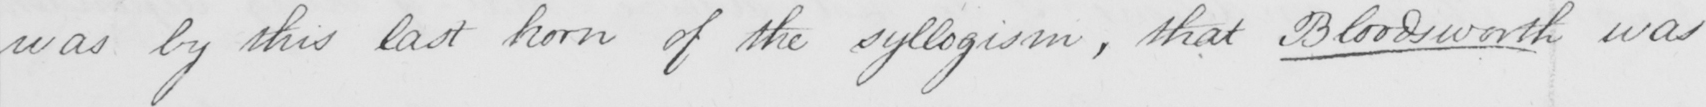Can you tell me what this handwritten text says? was by this last horn of the syllogism , that Bloodsworth was 